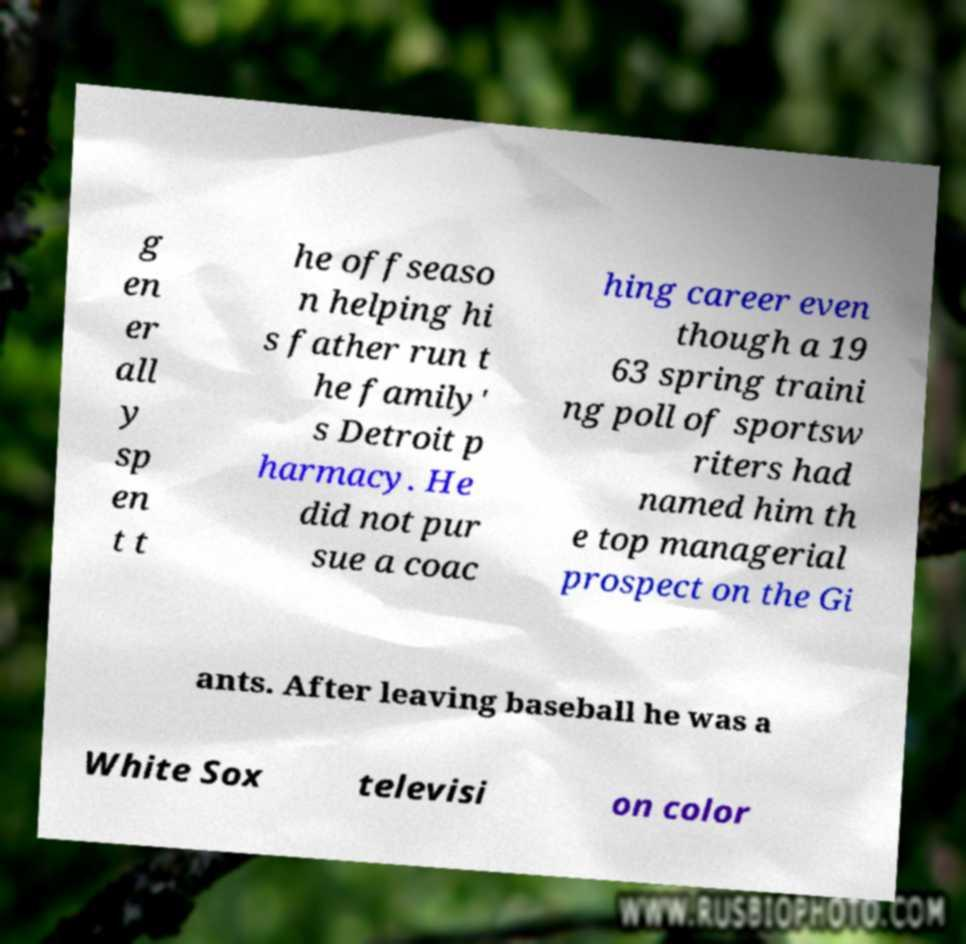Could you extract and type out the text from this image? g en er all y sp en t t he offseaso n helping hi s father run t he family' s Detroit p harmacy. He did not pur sue a coac hing career even though a 19 63 spring traini ng poll of sportsw riters had named him th e top managerial prospect on the Gi ants. After leaving baseball he was a White Sox televisi on color 